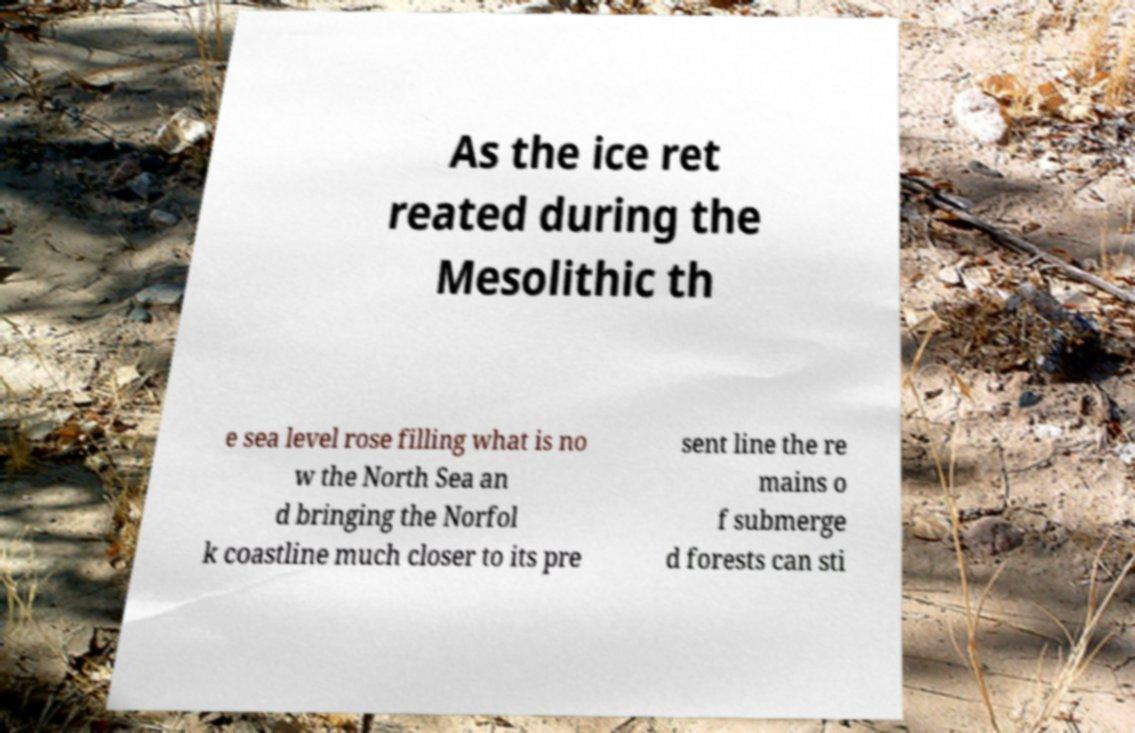What messages or text are displayed in this image? I need them in a readable, typed format. As the ice ret reated during the Mesolithic th e sea level rose filling what is no w the North Sea an d bringing the Norfol k coastline much closer to its pre sent line the re mains o f submerge d forests can sti 